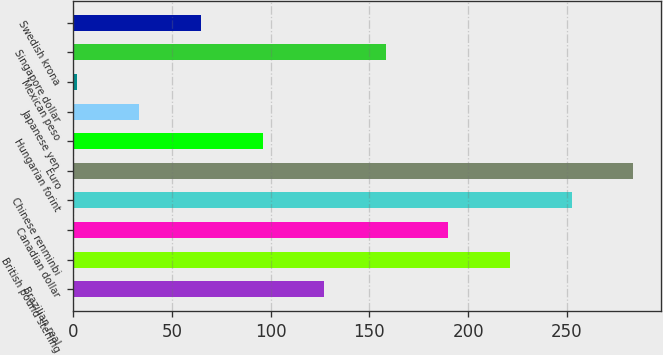Convert chart. <chart><loc_0><loc_0><loc_500><loc_500><bar_chart><fcel>Brazilian real<fcel>British pound sterling<fcel>Canadian dollar<fcel>Chinese renminbi<fcel>Euro<fcel>Hungarian forint<fcel>Japanese yen<fcel>Mexican peso<fcel>Singapore dollar<fcel>Swedish krona<nl><fcel>127.2<fcel>221.1<fcel>189.8<fcel>252.4<fcel>283.7<fcel>95.9<fcel>33.3<fcel>2<fcel>158.5<fcel>64.6<nl></chart> 